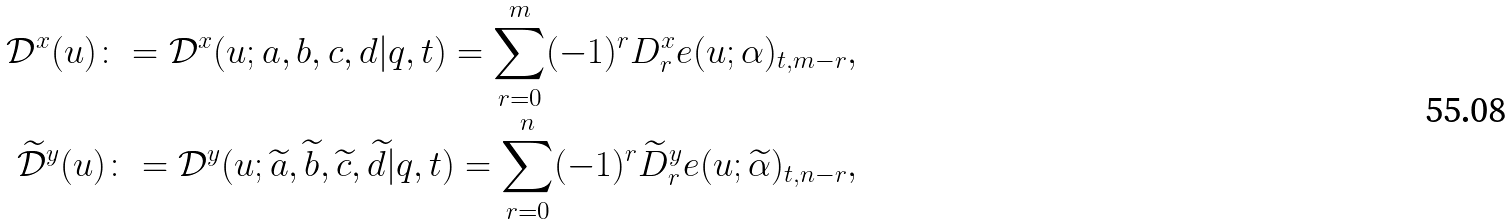Convert formula to latex. <formula><loc_0><loc_0><loc_500><loc_500>\mathcal { D } ^ { x } ( u ) \colon = \mathcal { D } ^ { x } ( u ; a , b , c , d | q , t ) = \sum _ { r = 0 } ^ { m } ( - 1 ) ^ { r } D _ { r } ^ { x } e ( u ; \alpha ) _ { t , m - r } , \\ \widetilde { \mathcal { D } } ^ { y } ( u ) \colon = \mathcal { D } ^ { y } ( u ; \widetilde { a } , \widetilde { b } , \widetilde { c } , \widetilde { d } | q , t ) = \sum _ { r = 0 } ^ { n } ( - 1 ) ^ { r } \widetilde { D } _ { r } ^ { y } e ( u ; \widetilde { \alpha } ) _ { t , n - r } ,</formula> 